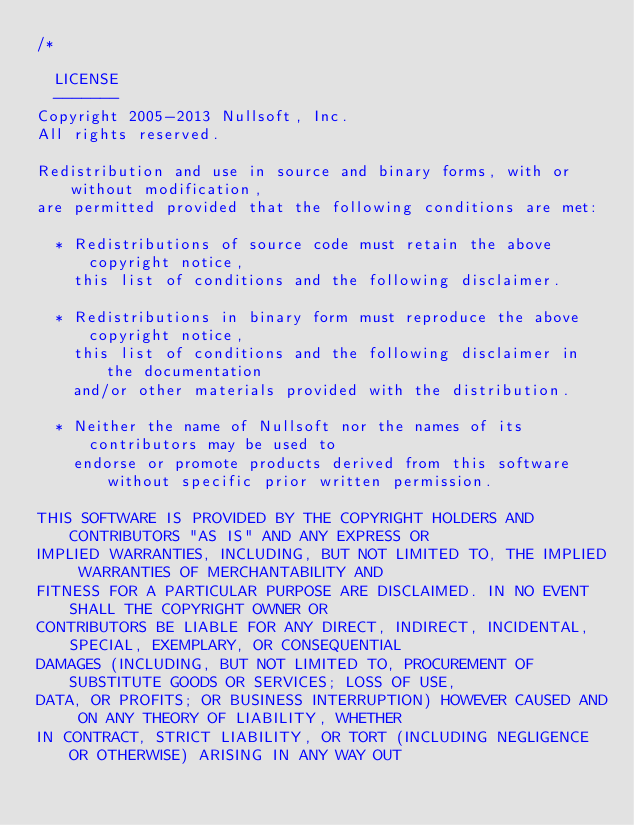Convert code to text. <code><loc_0><loc_0><loc_500><loc_500><_C_>/*

  LICENSE
  -------
Copyright 2005-2013 Nullsoft, Inc.
All rights reserved.

Redistribution and use in source and binary forms, with or without modification, 
are permitted provided that the following conditions are met:

  * Redistributions of source code must retain the above copyright notice,
    this list of conditions and the following disclaimer. 

  * Redistributions in binary form must reproduce the above copyright notice,
    this list of conditions and the following disclaimer in the documentation
    and/or other materials provided with the distribution. 

  * Neither the name of Nullsoft nor the names of its contributors may be used to 
    endorse or promote products derived from this software without specific prior written permission. 
 
THIS SOFTWARE IS PROVIDED BY THE COPYRIGHT HOLDERS AND CONTRIBUTORS "AS IS" AND ANY EXPRESS OR 
IMPLIED WARRANTIES, INCLUDING, BUT NOT LIMITED TO, THE IMPLIED WARRANTIES OF MERCHANTABILITY AND 
FITNESS FOR A PARTICULAR PURPOSE ARE DISCLAIMED. IN NO EVENT SHALL THE COPYRIGHT OWNER OR 
CONTRIBUTORS BE LIABLE FOR ANY DIRECT, INDIRECT, INCIDENTAL, SPECIAL, EXEMPLARY, OR CONSEQUENTIAL
DAMAGES (INCLUDING, BUT NOT LIMITED TO, PROCUREMENT OF SUBSTITUTE GOODS OR SERVICES; LOSS OF USE,
DATA, OR PROFITS; OR BUSINESS INTERRUPTION) HOWEVER CAUSED AND ON ANY THEORY OF LIABILITY, WHETHER
IN CONTRACT, STRICT LIABILITY, OR TORT (INCLUDING NEGLIGENCE OR OTHERWISE) ARISING IN ANY WAY OUT </code> 